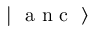<formula> <loc_0><loc_0><loc_500><loc_500>{ | \mathrm { a n c } \rangle }</formula> 